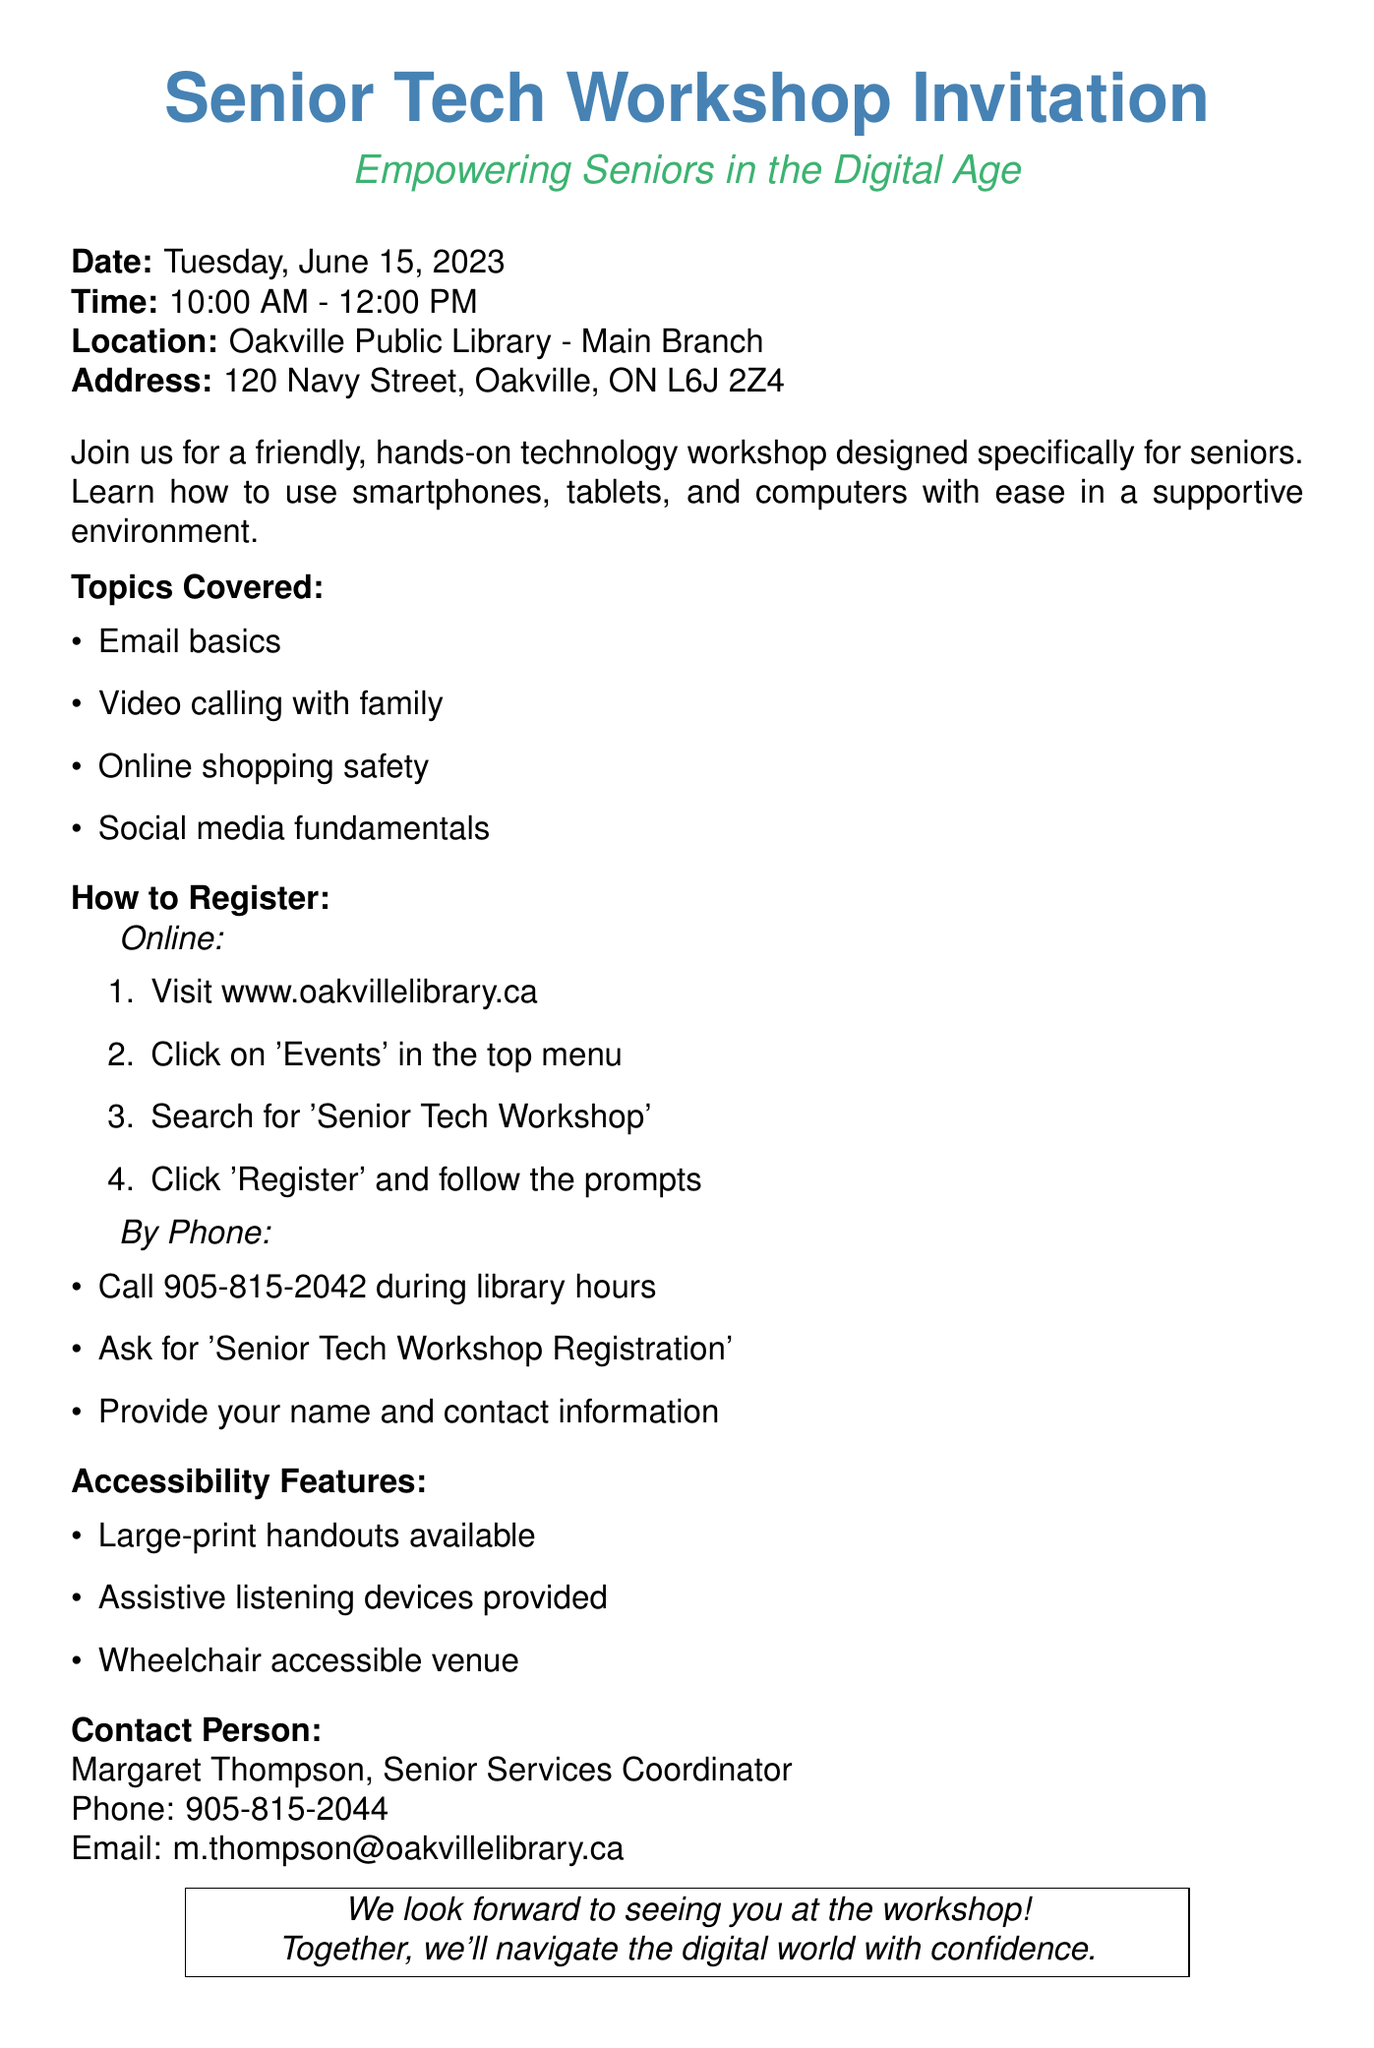What is the date of the workshop? The workshop is scheduled for Tuesday, June 15, 2023.
Answer: Tuesday, June 15, 2023 What time does the workshop start? The workshop starts at 10:00 AM.
Answer: 10:00 AM Where is the workshop being held? The workshop is at the Oakville Public Library - Main Branch.
Answer: Oakville Public Library - Main Branch Who should I contact for more information? The contact person for the workshop is Margaret Thompson, the Senior Services Coordinator.
Answer: Margaret Thompson What topics will be covered in the workshop? The workshop will cover email basics, video calling, online shopping safety, and social media fundamentals.
Answer: Email basics, video calling, online shopping safety, social media fundamentals How can I register online? To register online, visit the Oakville library website and follow the prompts for the Senior Tech Workshop.
Answer: Visit www.oakvillelibrary.ca Is the venue wheelchair accessible? Yes, the venue is wheelchair accessible.
Answer: Wheelchair accessible venue What is the phone number for registration? The phone number to register for the workshop is 905-815-2042.
Answer: 905-815-2042 